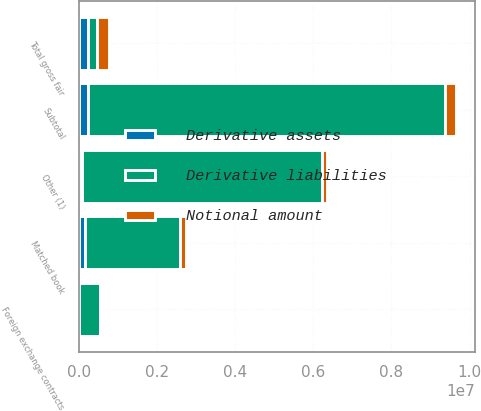Convert chart to OTSL. <chart><loc_0><loc_0><loc_500><loc_500><stacked_bar_chart><ecel><fcel>Matched book<fcel>Other (1)<fcel>Foreign exchange contracts<fcel>Subtotal<fcel>Total gross fair<nl><fcel>Derivative assets<fcel>160345<fcel>74068<fcel>1141<fcel>235554<fcel>235554<nl><fcel>Notional amount<fcel>160345<fcel>112864<fcel>1454<fcel>290243<fcel>293766<nl><fcel>Derivative liabilities<fcel>2.41562e+06<fcel>6.15561e+06<fcel>549188<fcel>9.13599e+06<fcel>235554<nl></chart> 